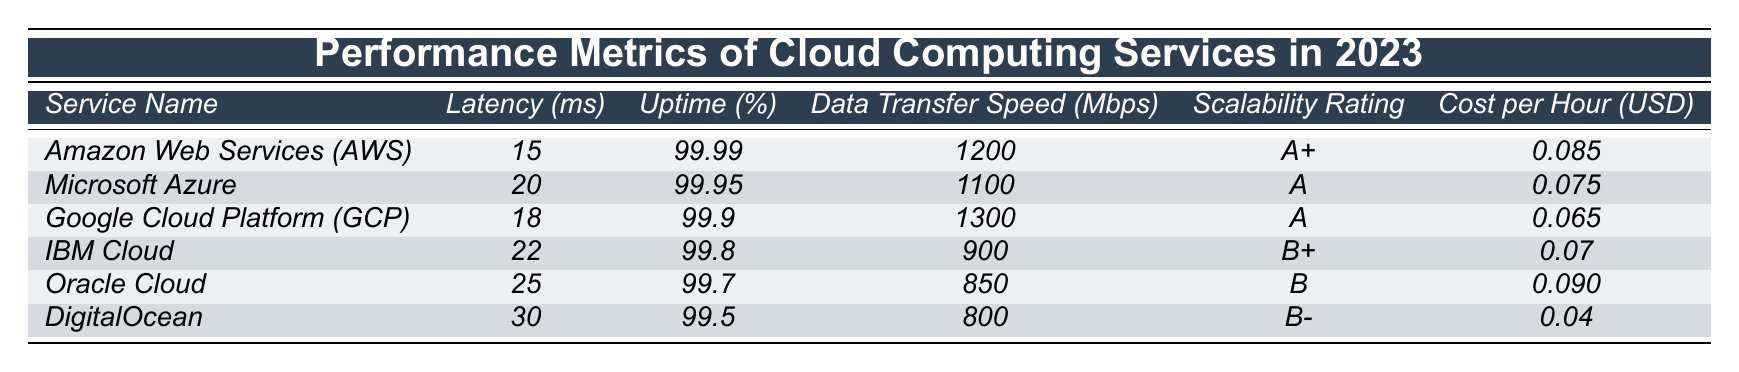What is the data transfer speed of Google Cloud Platform? The table indicates that the data transfer speed for Google Cloud Platform (GCP) is listed as 1300 Mbps.
Answer: 1300 Mbps Which cloud service has the lowest cost per hour? By comparing the cost per hour for all services in the table, DigitalOcean has the lowest cost at 0.04 USD.
Answer: 0.04 USD Is the uptime percentage for IBM Cloud greater than 99.8%? The table shows that IBM Cloud has an uptime percentage of 99.8%, which is not greater than this value.
Answer: No Which service has a higher latency: Amazon Web Services or Microsoft Azure? According to the table, Amazon Web Services has a latency of 15 ms, while Microsoft Azure has a latency of 20 ms. Since 20 ms is greater, Microsoft Azure has higher latency.
Answer: Microsoft Azure What is the average latency of the cloud services listed? The latencies are 15, 20, 18, 22, 25, and 30 ms. Adding these values gives a total of 130 ms, and dividing by the number of services (6) yields an average latency of about 21.67 ms.
Answer: 21.67 ms How much more does Oracle Cloud cost per hour compared to DigitalOcean? Oracle Cloud costs 0.090 USD per hour, and DigitalOcean costs 0.04 USD. The difference is 0.090 - 0.04 = 0.050 USD.
Answer: 0.050 USD Is the scalability rating of Google Cloud Platform the same as that of Microsoft Azure? Google Cloud Platform has a scalability rating of A, while Microsoft Azure has a rating of A. Since they are both rated A, they are the same.
Answer: Yes Which two cloud services have an uptime percentage above 99.9%? From the table, the services with an uptime above 99.9% are Amazon Web Services (99.99%) and Microsoft Azure (99.95%).
Answer: Amazon Web Services and Microsoft Azure What is the range of the scalability ratings among the listed cloud services? The highest scalability rating is A+ (AWS) and the lowest is B- (DigitalOcean). The range is from B- to A+.
Answer: B- to A+ Which cloud service has both the highest data transfer speed and lowest latency? Google Cloud Platform has the highest data transfer speed of 1300 Mbps but a latency of 18 ms, which is lower than AWS's 15 ms in latency but higher in speed. Therefore, no service has both.
Answer: None 